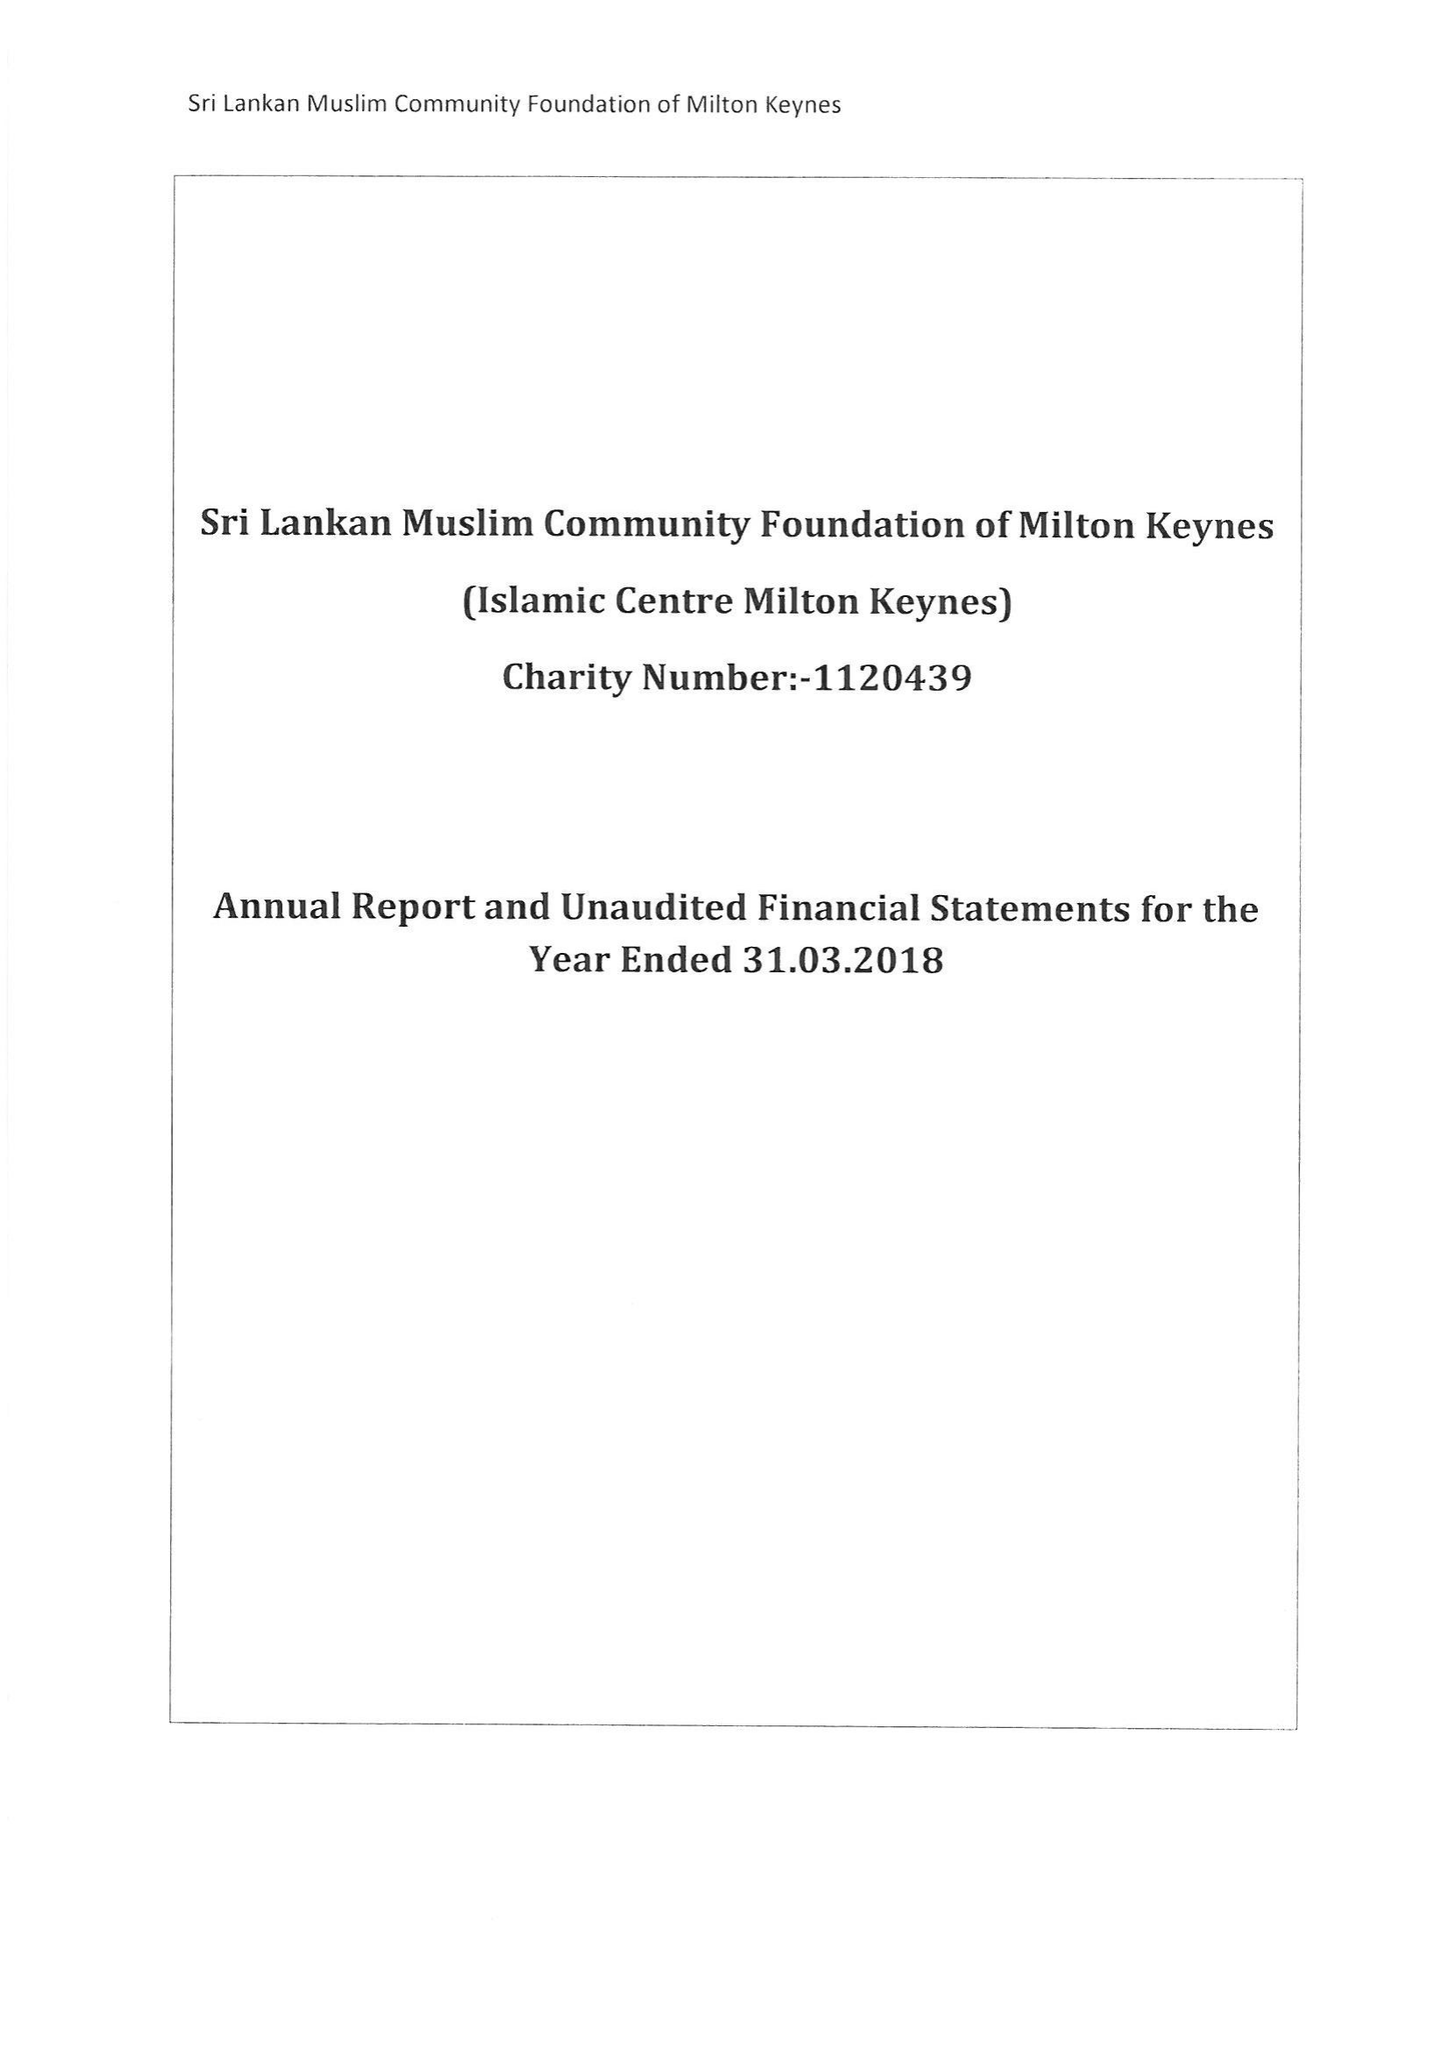What is the value for the address__street_line?
Answer the question using a single word or phrase. 21 FISHERMEAD BOULEVARD 